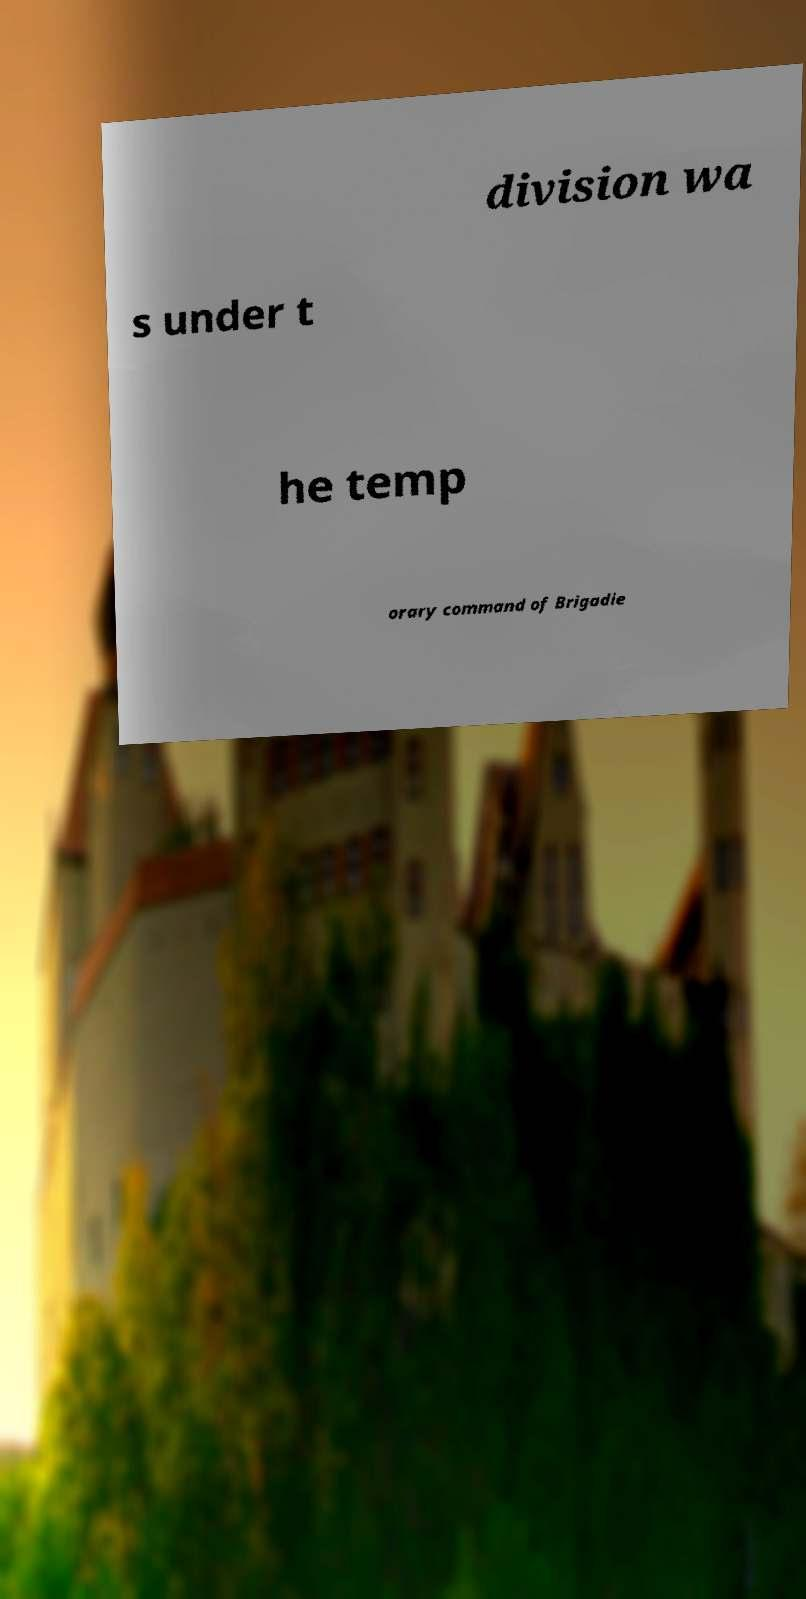What messages or text are displayed in this image? I need them in a readable, typed format. division wa s under t he temp orary command of Brigadie 